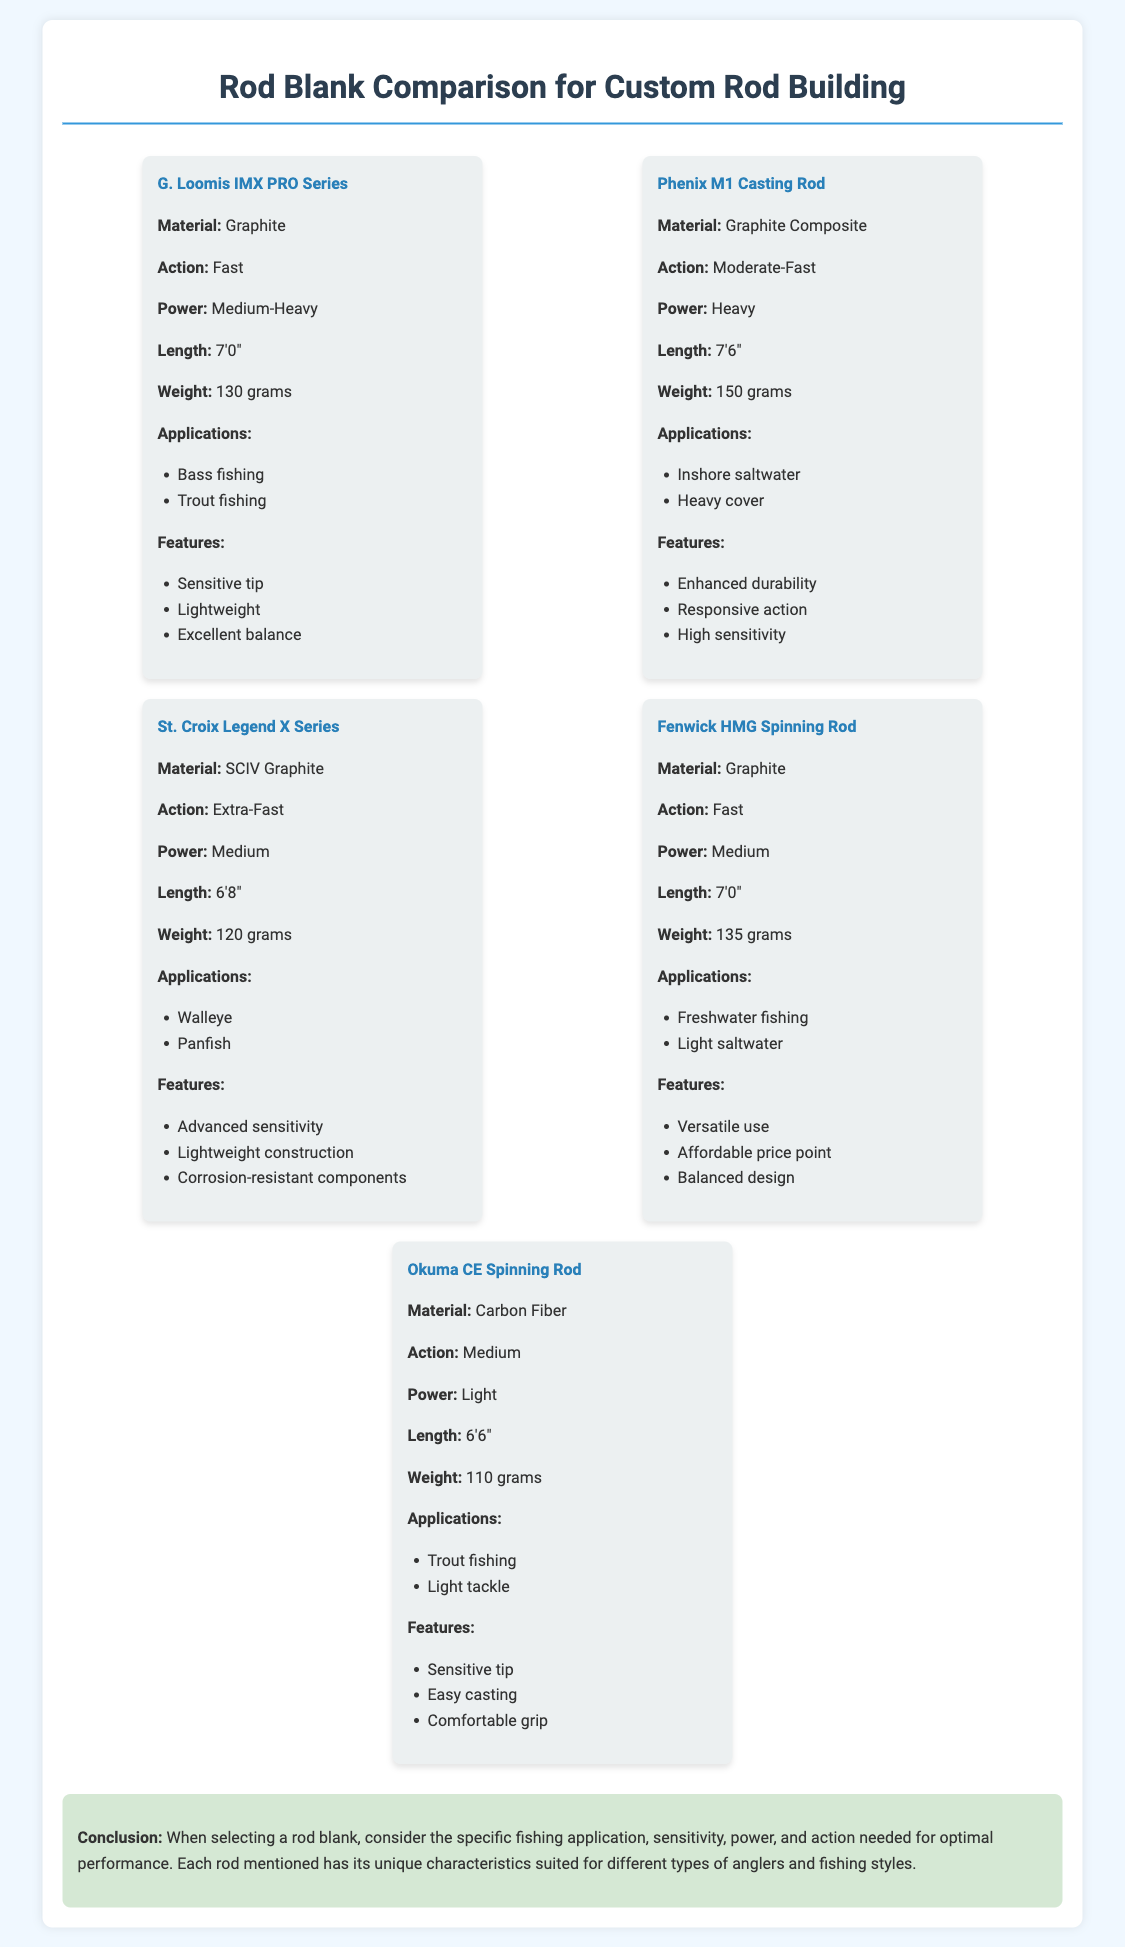What is the weight of the G. Loomis IMX PRO Series rod? The weight of the G. Loomis IMX PRO Series rod is stated in the document as 130 grams.
Answer: 130 grams What action does the Phenix M1 Casting Rod have? The action of the Phenix M1 Casting Rod is explicitly mentioned as Moderate-Fast in the document.
Answer: Moderate-Fast Which rod is designed for walleye fishing? The document lists the St. Croix Legend X Series as suitable for walleye fishing in its applications section.
Answer: St. Croix Legend X Series What material is the Okuma CE Spinning Rod made of? The material of the Okuma CE Spinning Rod is specified as Carbon Fiber in the document.
Answer: Carbon Fiber Which rod has the highest weight? To find the rod with the highest weight, we compare the weights listed and find that the Phenix M1 Casting Rod weighs 150 grams.
Answer: 150 grams What is a unique feature of the Fenwick HMG Spinning Rod? The document lists various features of the Fenwick HMG Spinning Rod, highlighting its affordable price point as a unique feature.
Answer: Affordable price point Which rod is recommended for panfish? According to the applications section in the document, the St. Croix Legend X Series is recommended for panfish.
Answer: St. Croix Legend X Series What length is the G. Loomis IMX PRO Series rod? The length of the G. Loomis IMX PRO Series rod is stated in the document as 7'0".
Answer: 7'0" What type of fishing is the Okuma CE Spinning Rod suited for? The document mentions that the Okuma CE Spinning Rod is suitable for trout fishing in its applications.
Answer: Trout fishing 